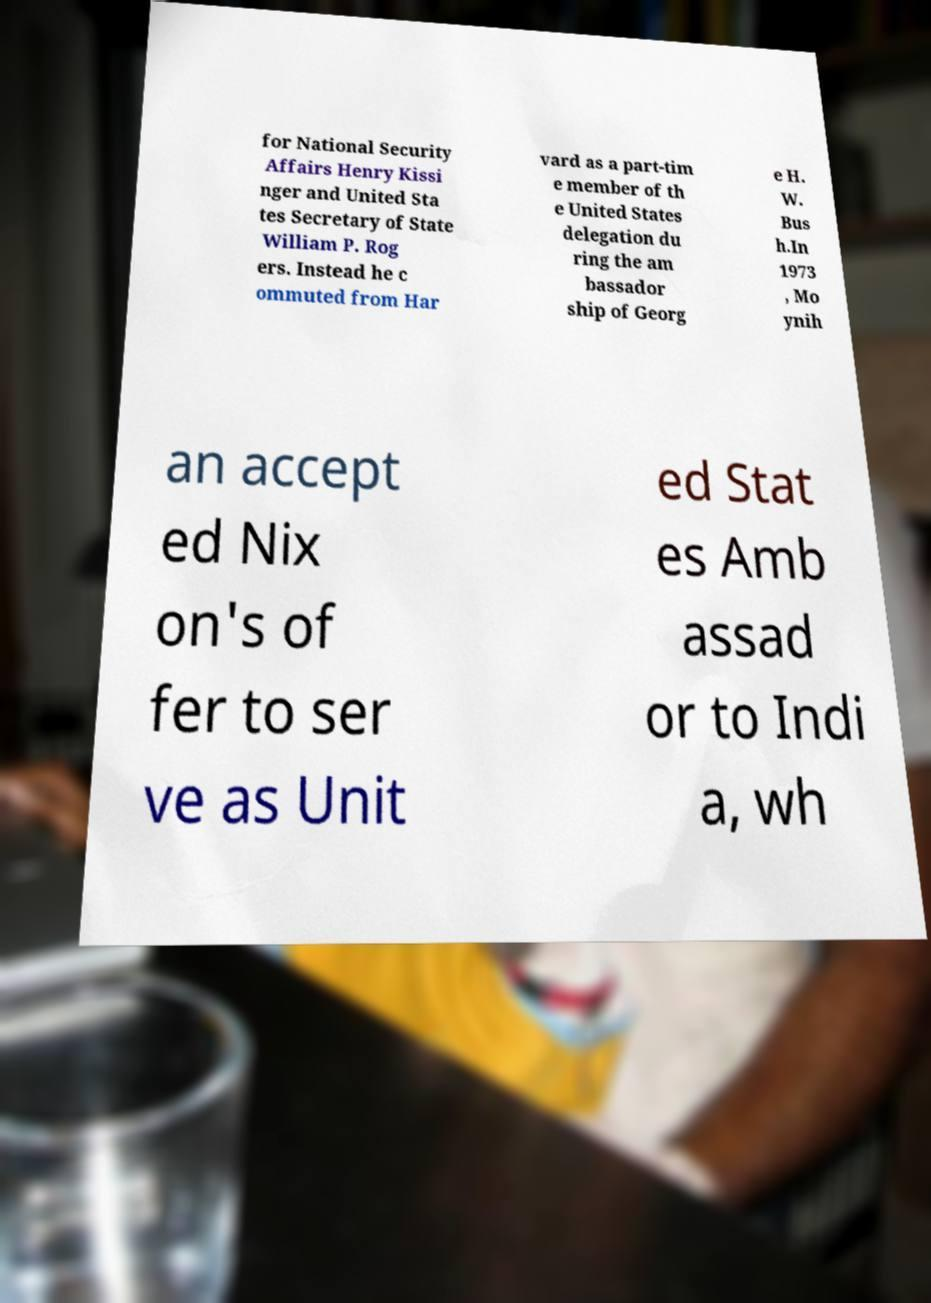Please read and relay the text visible in this image. What does it say? for National Security Affairs Henry Kissi nger and United Sta tes Secretary of State William P. Rog ers. Instead he c ommuted from Har vard as a part-tim e member of th e United States delegation du ring the am bassador ship of Georg e H. W. Bus h.In 1973 , Mo ynih an accept ed Nix on's of fer to ser ve as Unit ed Stat es Amb assad or to Indi a, wh 